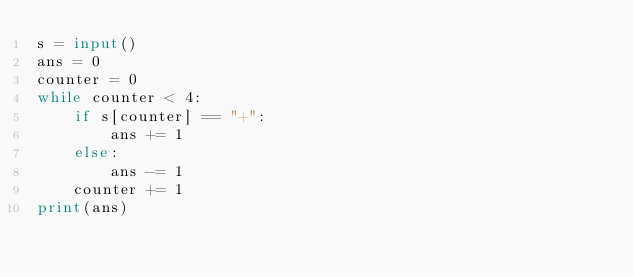Convert code to text. <code><loc_0><loc_0><loc_500><loc_500><_Python_>s = input()
ans = 0
counter = 0
while counter < 4:
    if s[counter] == "+":
        ans += 1
    else:
        ans -= 1
    counter += 1
print(ans)</code> 